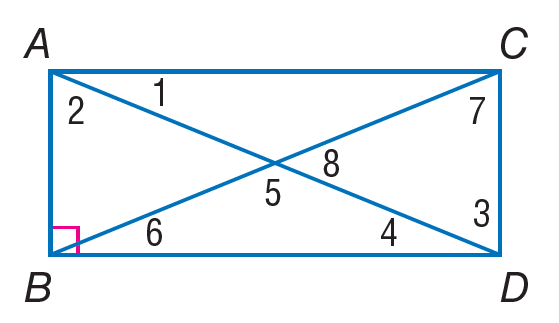Answer the mathemtical geometry problem and directly provide the correct option letter.
Question: Quadrilateral A B D C is a rectangle. Find m \angle 5 if m \angle 1 = 38.
Choices: A: 45 B: 76 C: 104 D: 130 C 